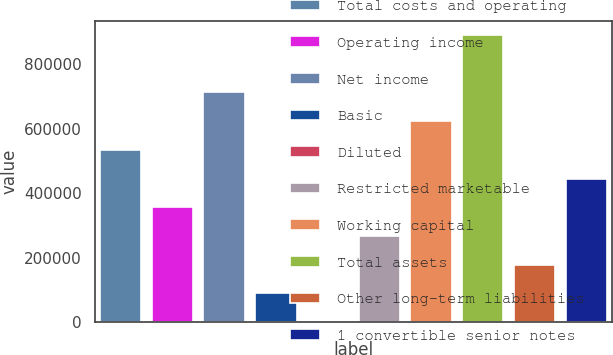Convert chart. <chart><loc_0><loc_0><loc_500><loc_500><bar_chart><fcel>Total costs and operating<fcel>Operating income<fcel>Net income<fcel>Basic<fcel>Diluted<fcel>Restricted marketable<fcel>Working capital<fcel>Total assets<fcel>Other long-term liabilities<fcel>1 convertible senior notes<nl><fcel>534900<fcel>356601<fcel>713200<fcel>89151.8<fcel>2.11<fcel>267451<fcel>624050<fcel>891499<fcel>178301<fcel>445751<nl></chart> 